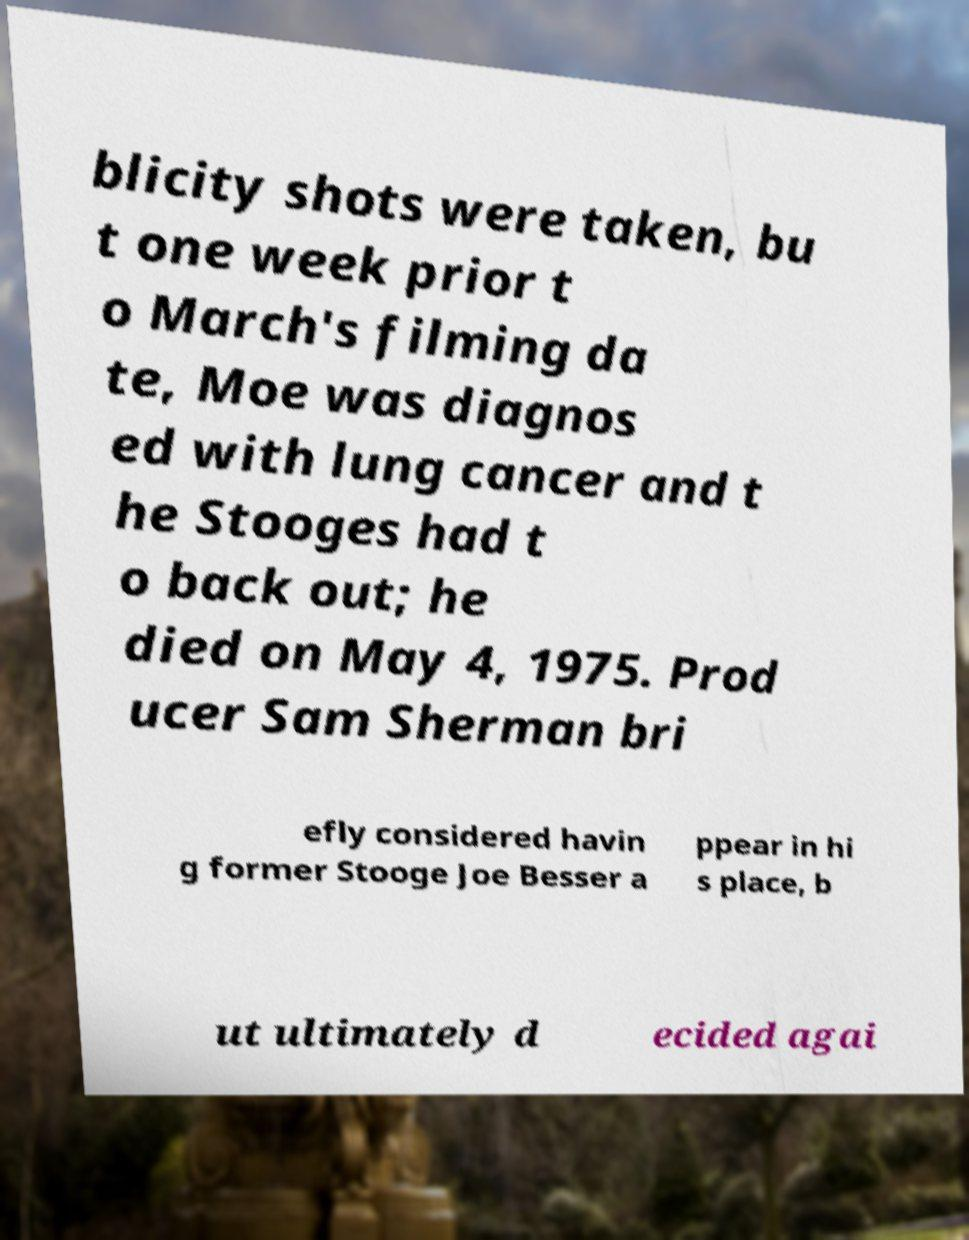Could you extract and type out the text from this image? blicity shots were taken, bu t one week prior t o March's filming da te, Moe was diagnos ed with lung cancer and t he Stooges had t o back out; he died on May 4, 1975. Prod ucer Sam Sherman bri efly considered havin g former Stooge Joe Besser a ppear in hi s place, b ut ultimately d ecided agai 